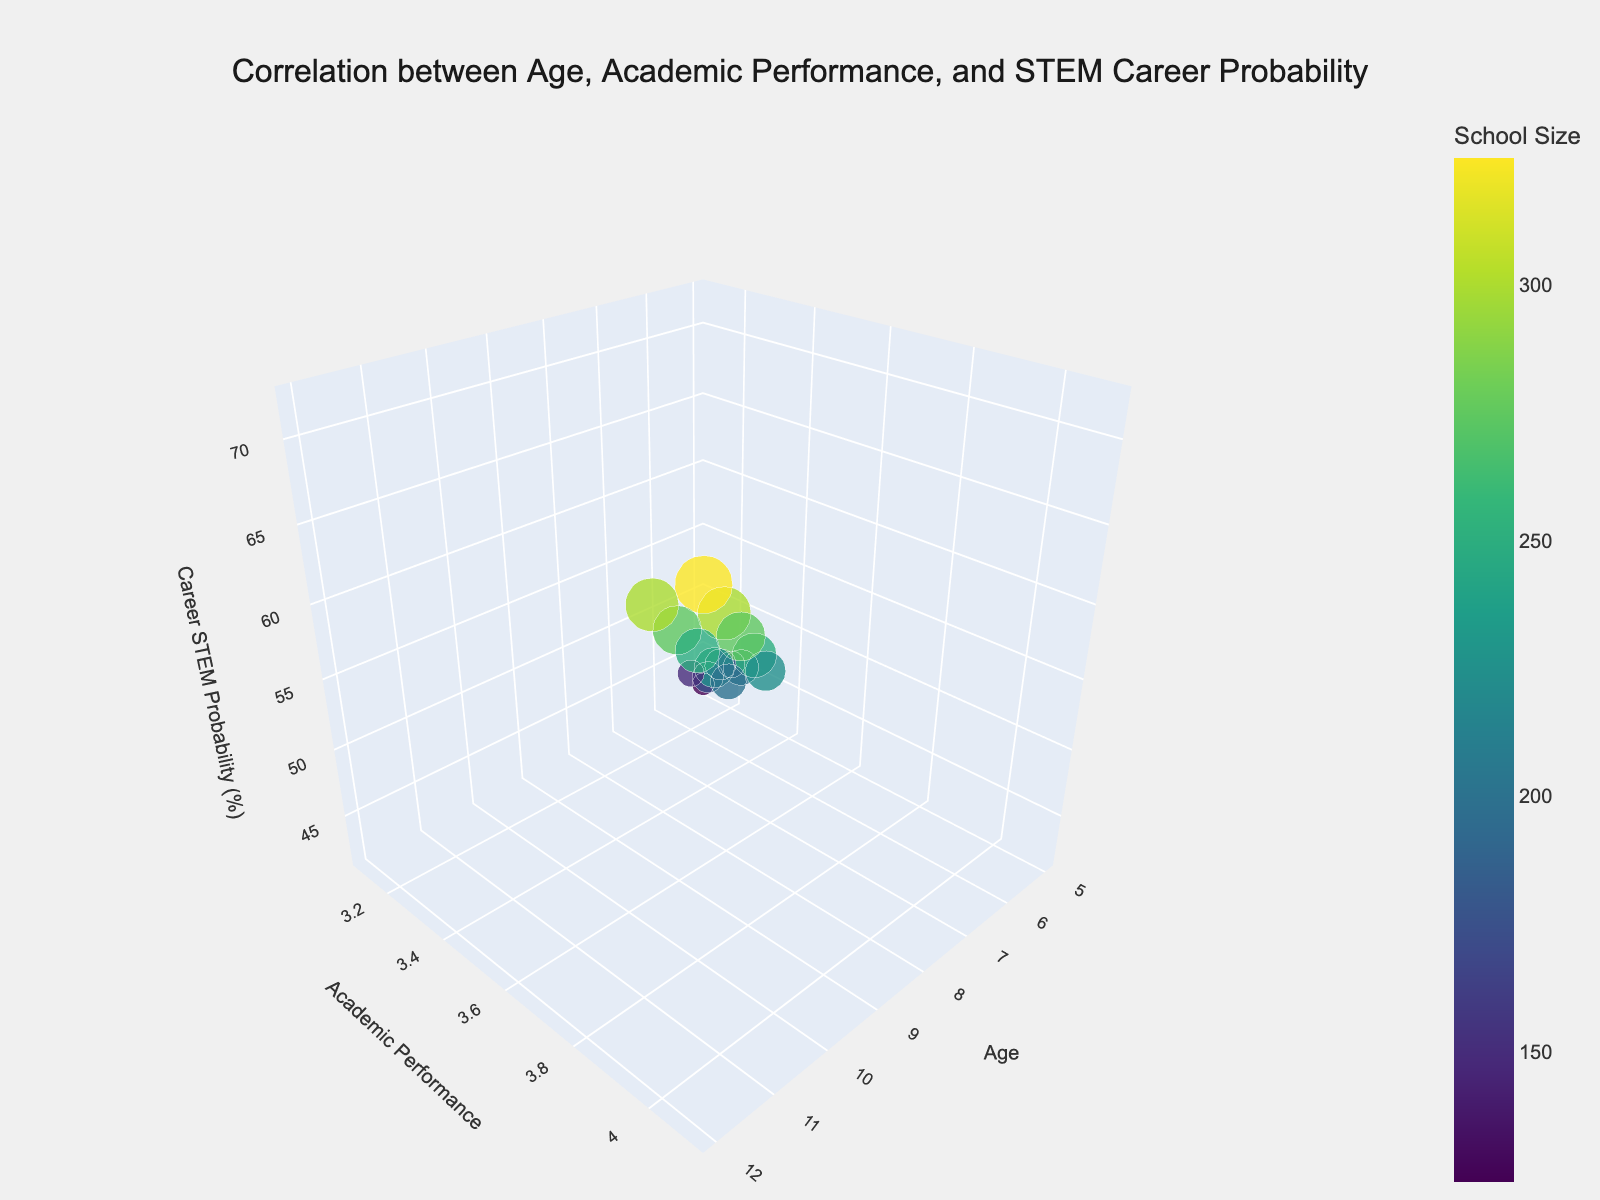what is the title of the figure? The title of the figure is located at the top of the chart, specifying the main focus of the visual data representation. The title is "Correlation between Age, Academic Performance, and STEM Career Probability".
Answer: Correlation between Age, Academic Performance, and STEM Career Probability What does the color of the bubbles represent? The color of the bubbles is explained by the color bar present in the figure. It shows that the color represents the school size. Darker bubbles indicate smaller schools, and lighter bubbles indicate larger schools.
Answer: School size How many age groups are represented in the chart? By examining the x-axis, we can see that ages range from 5 to 12. Each unique value represents a different age group. Therefore, there are 8 distinct age groups.
Answer: 8 Which age group seems to have the highest STEM career probability and what is its probability? Observing the z-axis, which denotes STEM career probability, and finding the highest point on this axis shows that age 12 has the highest STEM career probability, highlighted by the topmost bubble at this age group. Its probability is 72%.
Answer: 12, 72% What is the relationship between academic performance and career STEM probability? Observing the y-axis for academic performance and the z-axis for career STEM probability, we can see a positive correlation. As academic performance (y-axis) increases, career STEM probability (z-axis) also increases.
Answer: Positive correlation What is the average academic performance for the age groups depicted? To find the average academic performance, sum all the academic performance values of each age group and divide by the number of groups. Summing 3.2+3.5+3.8+4.0+3.3+3.7+3.9+4.1+3.1+3.4+3.7+3.9+3.2+3.6+3.8+4.0 yields 60.2. Dividing by 16 (number of data points/groups) yields an average of approximately 3.76.
Answer: 3.76 Compare the academic performance of 7-year-olds to 11-year-olds. Looking at the y-axis for academic performance at ages 7 and 11, we find the values. For 7 years old: 3.4 and 3.5. For 11 years old: 3.9 and 4.0. The 11-year-olds have a higher academic performance than the 7-year-olds.
Answer: 11-year-olds perform better academically Which school size appears most frequently in the data? By observing the bubble sizes, which correlate with school size, and repeating patterns, 150 appears three times, more frequently than any other school size.
Answer: 150 